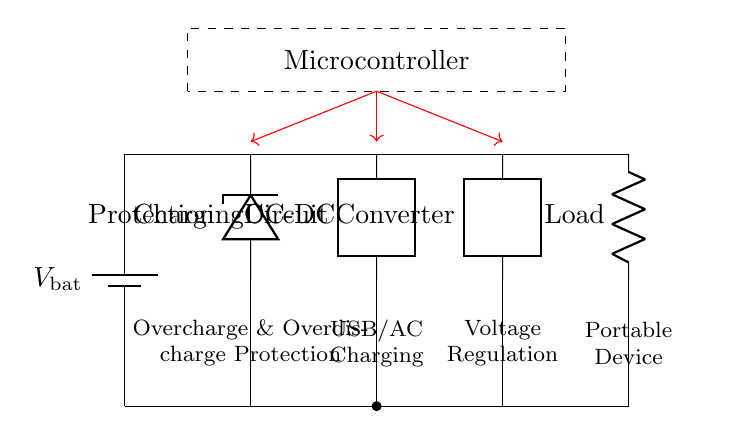What is the voltage source in this circuit? The voltage source is the battery, indicated as \( V_{\text{bat}} \), which is supplying power to the circuit.
Answer: Battery What is the function of the component labeled as "Protection"? The protection component is a diode, providing overcharge and overdischarge protection, preventing damage to the battery and circuit.
Answer: Overcharge and Overdischarge Protection What type of circuit is used for charging in this diagram? The circuit mentioned for charging is labeled as "Charging Circuit", and it indicates it can handle both USB and AC power sources for battery charging.
Answer: Charging Circuit Which component regulates the output voltage to the load? The "DC-DC Converter" is responsible for regulating the voltage supplied to the load, ensuring it receives a stable current for operation.
Answer: DC-DC Converter What is the role of the microcontroller in this circuit? The microcontroller is tasked with controlling the operation of the charging circuit, battery protection mechanism, and DC-DC converter to optimize performance.
Answer: Control How many key functional units are present in this battery management circuit? The functional units include a battery, protection circuit, charging circuit, DC-DC converter, and load, totaling five main units interacting within the circuit.
Answer: Five Which part of the circuit ensures voltage stability during discharge? The "DC-DC Converter" ensures that the voltage remains stable during the discharge process to the connected load, preventing voltage drops that could affect device performance.
Answer: DC-DC Converter 